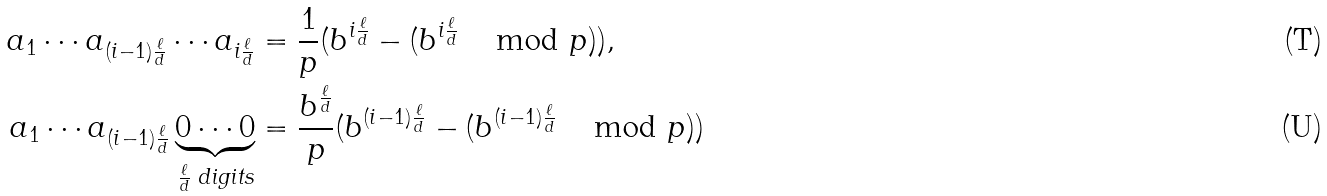<formula> <loc_0><loc_0><loc_500><loc_500>a _ { 1 } \cdots a _ { ( i - 1 ) \frac { \ell } { d } } \cdots a _ { i \frac { \ell } { d } } & = \frac { 1 } { p } ( b ^ { i \frac { \ell } { d } } - ( b ^ { i \frac { \ell } { d } } \, \mod p ) ) , \\ a _ { 1 } \cdots a _ { ( i - 1 ) \frac { \ell } { d } } \underbrace { 0 \cdots 0 } _ { \frac { \ell } { d } \text { digits} } & = \frac { b ^ { \frac { \ell } { d } } } { p } ( b ^ { ( i - 1 ) \frac { \ell } { d } } - ( b ^ { ( i - 1 ) \frac { \ell } { d } } \, \mod p ) )</formula> 